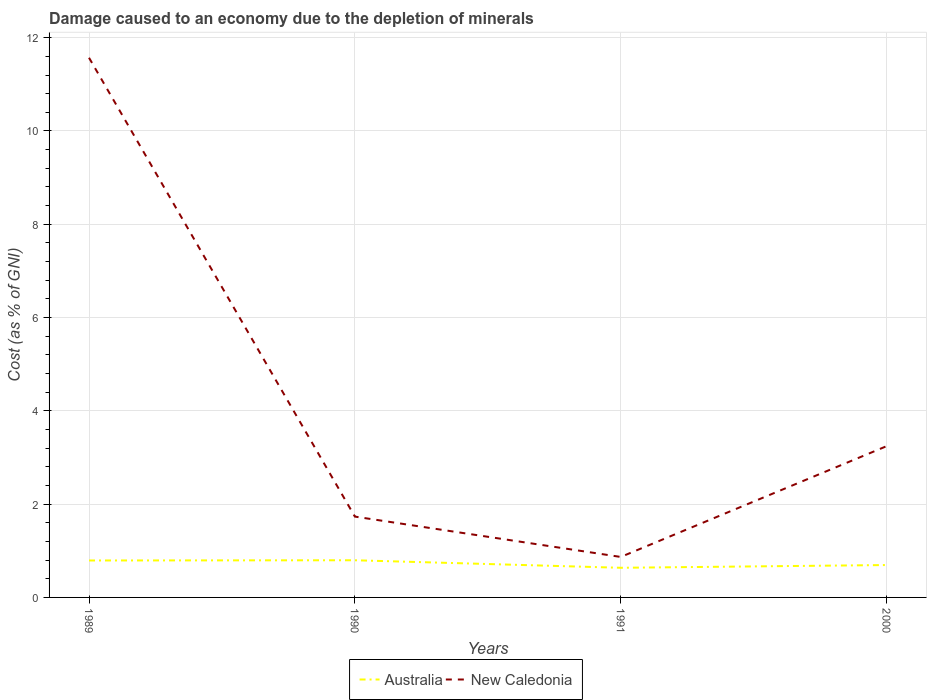How many different coloured lines are there?
Your answer should be compact. 2. Does the line corresponding to Australia intersect with the line corresponding to New Caledonia?
Offer a very short reply. No. Is the number of lines equal to the number of legend labels?
Provide a short and direct response. Yes. Across all years, what is the maximum cost of damage caused due to the depletion of minerals in Australia?
Give a very brief answer. 0.64. In which year was the cost of damage caused due to the depletion of minerals in Australia maximum?
Provide a succinct answer. 1991. What is the total cost of damage caused due to the depletion of minerals in New Caledonia in the graph?
Give a very brief answer. 9.84. What is the difference between the highest and the second highest cost of damage caused due to the depletion of minerals in Australia?
Provide a short and direct response. 0.16. How many years are there in the graph?
Give a very brief answer. 4. Where does the legend appear in the graph?
Provide a succinct answer. Bottom center. How are the legend labels stacked?
Provide a short and direct response. Horizontal. What is the title of the graph?
Make the answer very short. Damage caused to an economy due to the depletion of minerals. What is the label or title of the Y-axis?
Your answer should be very brief. Cost (as % of GNI). What is the Cost (as % of GNI) in Australia in 1989?
Your response must be concise. 0.79. What is the Cost (as % of GNI) of New Caledonia in 1989?
Your response must be concise. 11.57. What is the Cost (as % of GNI) in Australia in 1990?
Make the answer very short. 0.8. What is the Cost (as % of GNI) of New Caledonia in 1990?
Give a very brief answer. 1.73. What is the Cost (as % of GNI) of Australia in 1991?
Your response must be concise. 0.64. What is the Cost (as % of GNI) of New Caledonia in 1991?
Offer a terse response. 0.87. What is the Cost (as % of GNI) in Australia in 2000?
Keep it short and to the point. 0.69. What is the Cost (as % of GNI) of New Caledonia in 2000?
Provide a succinct answer. 3.24. Across all years, what is the maximum Cost (as % of GNI) of Australia?
Ensure brevity in your answer.  0.8. Across all years, what is the maximum Cost (as % of GNI) of New Caledonia?
Your response must be concise. 11.57. Across all years, what is the minimum Cost (as % of GNI) of Australia?
Offer a terse response. 0.64. Across all years, what is the minimum Cost (as % of GNI) of New Caledonia?
Your answer should be compact. 0.87. What is the total Cost (as % of GNI) in Australia in the graph?
Ensure brevity in your answer.  2.92. What is the total Cost (as % of GNI) of New Caledonia in the graph?
Provide a short and direct response. 17.41. What is the difference between the Cost (as % of GNI) in Australia in 1989 and that in 1990?
Give a very brief answer. -0. What is the difference between the Cost (as % of GNI) of New Caledonia in 1989 and that in 1990?
Your response must be concise. 9.84. What is the difference between the Cost (as % of GNI) of Australia in 1989 and that in 1991?
Your response must be concise. 0.16. What is the difference between the Cost (as % of GNI) in New Caledonia in 1989 and that in 1991?
Your answer should be compact. 10.7. What is the difference between the Cost (as % of GNI) in Australia in 1989 and that in 2000?
Provide a succinct answer. 0.1. What is the difference between the Cost (as % of GNI) of New Caledonia in 1989 and that in 2000?
Offer a very short reply. 8.33. What is the difference between the Cost (as % of GNI) of Australia in 1990 and that in 1991?
Make the answer very short. 0.16. What is the difference between the Cost (as % of GNI) of New Caledonia in 1990 and that in 1991?
Offer a terse response. 0.87. What is the difference between the Cost (as % of GNI) of Australia in 1990 and that in 2000?
Offer a very short reply. 0.1. What is the difference between the Cost (as % of GNI) of New Caledonia in 1990 and that in 2000?
Keep it short and to the point. -1.51. What is the difference between the Cost (as % of GNI) in Australia in 1991 and that in 2000?
Ensure brevity in your answer.  -0.06. What is the difference between the Cost (as % of GNI) of New Caledonia in 1991 and that in 2000?
Provide a succinct answer. -2.38. What is the difference between the Cost (as % of GNI) of Australia in 1989 and the Cost (as % of GNI) of New Caledonia in 1990?
Provide a short and direct response. -0.94. What is the difference between the Cost (as % of GNI) in Australia in 1989 and the Cost (as % of GNI) in New Caledonia in 1991?
Ensure brevity in your answer.  -0.08. What is the difference between the Cost (as % of GNI) in Australia in 1989 and the Cost (as % of GNI) in New Caledonia in 2000?
Your response must be concise. -2.45. What is the difference between the Cost (as % of GNI) in Australia in 1990 and the Cost (as % of GNI) in New Caledonia in 1991?
Your answer should be compact. -0.07. What is the difference between the Cost (as % of GNI) of Australia in 1990 and the Cost (as % of GNI) of New Caledonia in 2000?
Your answer should be very brief. -2.45. What is the difference between the Cost (as % of GNI) in Australia in 1991 and the Cost (as % of GNI) in New Caledonia in 2000?
Offer a very short reply. -2.61. What is the average Cost (as % of GNI) of Australia per year?
Provide a succinct answer. 0.73. What is the average Cost (as % of GNI) in New Caledonia per year?
Offer a very short reply. 4.35. In the year 1989, what is the difference between the Cost (as % of GNI) of Australia and Cost (as % of GNI) of New Caledonia?
Your response must be concise. -10.78. In the year 1990, what is the difference between the Cost (as % of GNI) in Australia and Cost (as % of GNI) in New Caledonia?
Offer a very short reply. -0.94. In the year 1991, what is the difference between the Cost (as % of GNI) of Australia and Cost (as % of GNI) of New Caledonia?
Offer a terse response. -0.23. In the year 2000, what is the difference between the Cost (as % of GNI) in Australia and Cost (as % of GNI) in New Caledonia?
Offer a very short reply. -2.55. What is the ratio of the Cost (as % of GNI) in New Caledonia in 1989 to that in 1990?
Ensure brevity in your answer.  6.68. What is the ratio of the Cost (as % of GNI) of Australia in 1989 to that in 1991?
Give a very brief answer. 1.25. What is the ratio of the Cost (as % of GNI) of New Caledonia in 1989 to that in 1991?
Your response must be concise. 13.33. What is the ratio of the Cost (as % of GNI) of Australia in 1989 to that in 2000?
Offer a terse response. 1.14. What is the ratio of the Cost (as % of GNI) in New Caledonia in 1989 to that in 2000?
Your answer should be very brief. 3.57. What is the ratio of the Cost (as % of GNI) in Australia in 1990 to that in 1991?
Give a very brief answer. 1.25. What is the ratio of the Cost (as % of GNI) of New Caledonia in 1990 to that in 1991?
Give a very brief answer. 2. What is the ratio of the Cost (as % of GNI) in Australia in 1990 to that in 2000?
Ensure brevity in your answer.  1.15. What is the ratio of the Cost (as % of GNI) in New Caledonia in 1990 to that in 2000?
Ensure brevity in your answer.  0.53. What is the ratio of the Cost (as % of GNI) of Australia in 1991 to that in 2000?
Offer a terse response. 0.92. What is the ratio of the Cost (as % of GNI) in New Caledonia in 1991 to that in 2000?
Ensure brevity in your answer.  0.27. What is the difference between the highest and the second highest Cost (as % of GNI) of Australia?
Your answer should be very brief. 0. What is the difference between the highest and the second highest Cost (as % of GNI) of New Caledonia?
Provide a short and direct response. 8.33. What is the difference between the highest and the lowest Cost (as % of GNI) of Australia?
Your response must be concise. 0.16. What is the difference between the highest and the lowest Cost (as % of GNI) of New Caledonia?
Give a very brief answer. 10.7. 